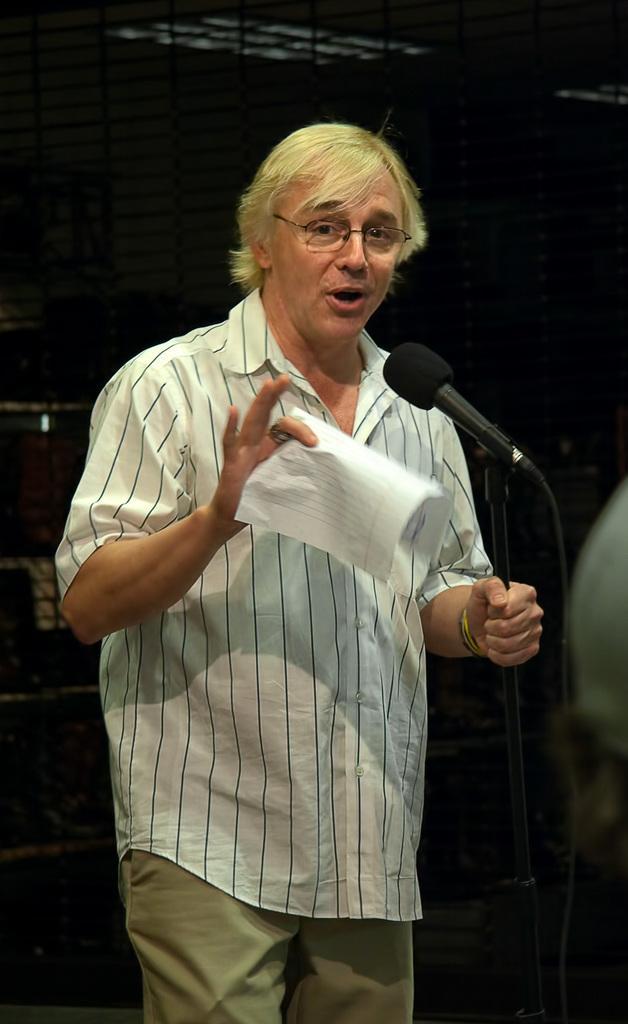Please provide a concise description of this image. In the picture we can see a man standing near the microphone, holding some paper in the hand and he is in a white shirt with lines on it. 